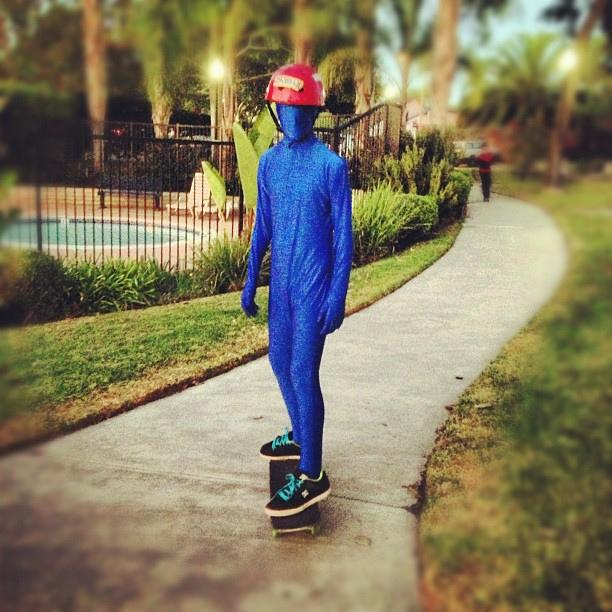What important property does this blue outfit have?

Choices:
A) breathable
B) washable
C) lightweight
D) waterproof breathable 